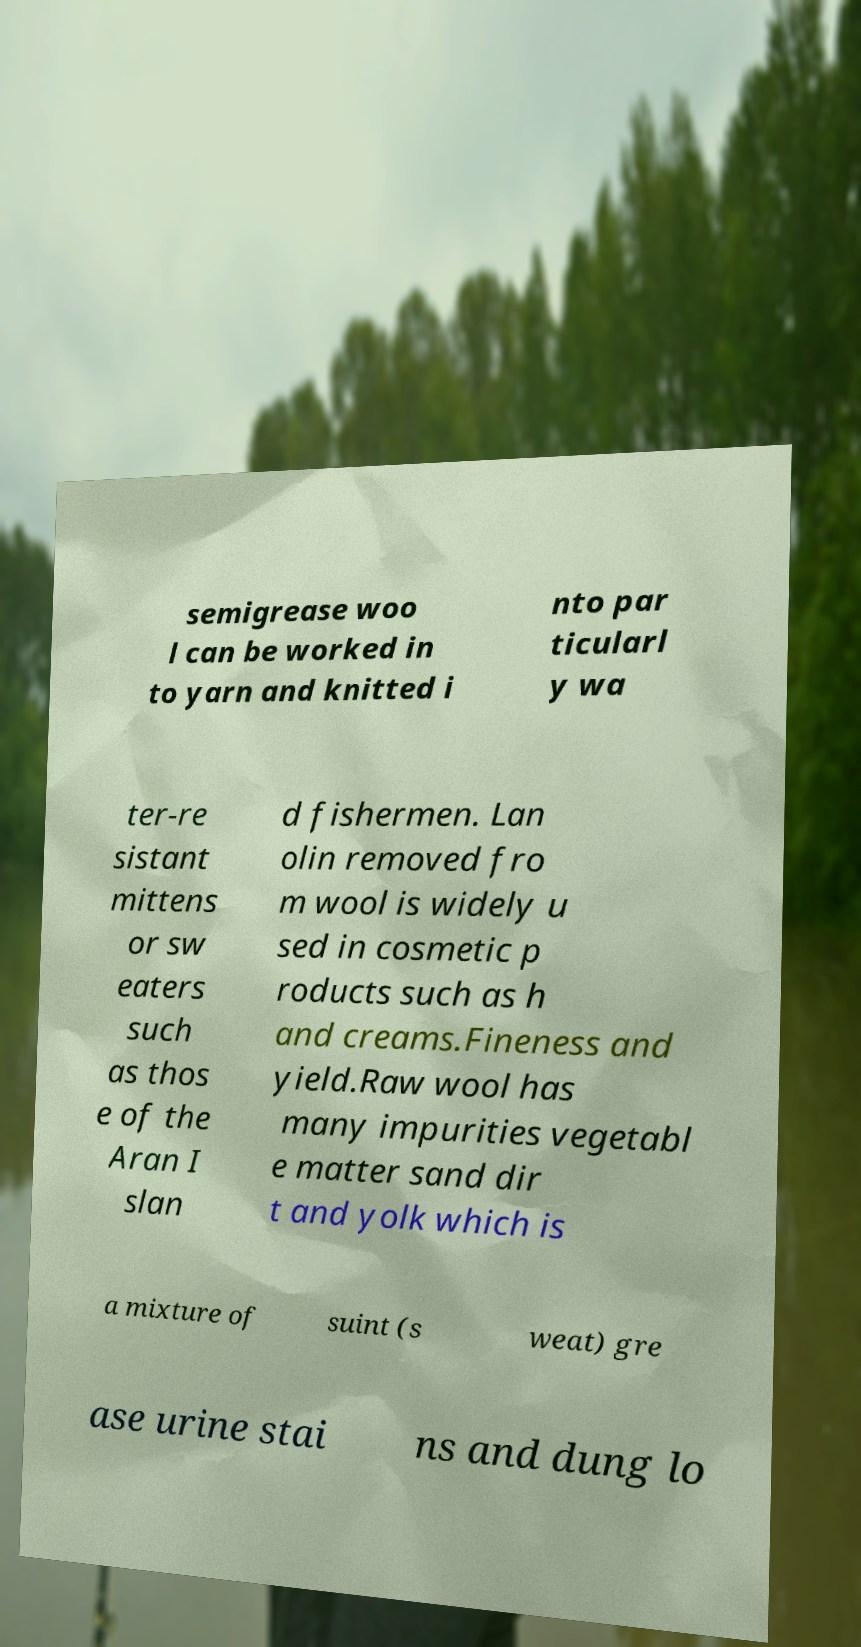Could you extract and type out the text from this image? semigrease woo l can be worked in to yarn and knitted i nto par ticularl y wa ter-re sistant mittens or sw eaters such as thos e of the Aran I slan d fishermen. Lan olin removed fro m wool is widely u sed in cosmetic p roducts such as h and creams.Fineness and yield.Raw wool has many impurities vegetabl e matter sand dir t and yolk which is a mixture of suint (s weat) gre ase urine stai ns and dung lo 